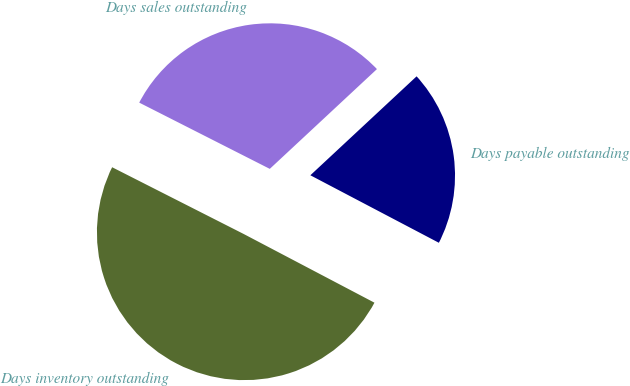Convert chart. <chart><loc_0><loc_0><loc_500><loc_500><pie_chart><fcel>Days sales outstanding<fcel>Days inventory outstanding<fcel>Days payable outstanding<nl><fcel>30.59%<fcel>49.77%<fcel>19.63%<nl></chart> 